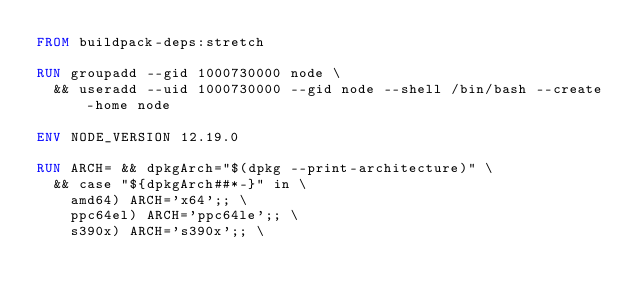<code> <loc_0><loc_0><loc_500><loc_500><_Dockerfile_>FROM buildpack-deps:stretch

RUN groupadd --gid 1000730000 node \
  && useradd --uid 1000730000 --gid node --shell /bin/bash --create-home node

ENV NODE_VERSION 12.19.0

RUN ARCH= && dpkgArch="$(dpkg --print-architecture)" \
  && case "${dpkgArch##*-}" in \
    amd64) ARCH='x64';; \
    ppc64el) ARCH='ppc64le';; \
    s390x) ARCH='s390x';; \</code> 